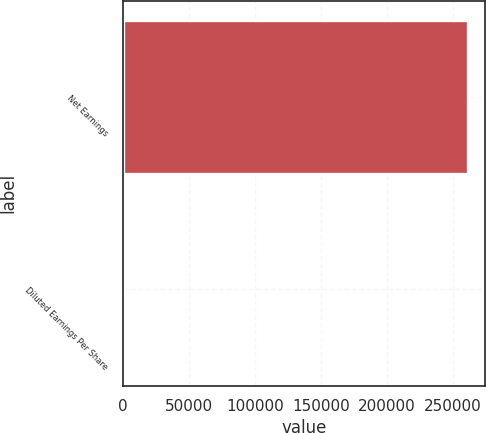Convert chart. <chart><loc_0><loc_0><loc_500><loc_500><bar_chart><fcel>Net Earnings<fcel>Diluted Earnings Per Share<nl><fcel>261406<fcel>0.48<nl></chart> 